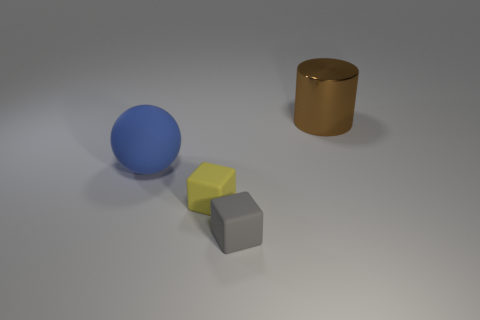Is there anything else that has the same material as the brown cylinder?
Provide a short and direct response. No. There is a big thing in front of the large thing behind the large blue rubber thing; are there any large objects behind it?
Your answer should be very brief. Yes. There is a matte cube behind the gray object; how big is it?
Offer a very short reply. Small. What material is the brown cylinder that is the same size as the blue thing?
Your answer should be very brief. Metal. Does the gray rubber thing have the same shape as the yellow object?
Provide a succinct answer. Yes. How many objects are either large purple matte blocks or big objects that are to the left of the large brown object?
Ensure brevity in your answer.  1. Is the size of the matte object to the left of the yellow matte cube the same as the brown metallic object?
Make the answer very short. Yes. How many brown metal things are on the left side of the big thing that is to the left of the thing behind the big blue matte thing?
Provide a succinct answer. 0. What number of green objects are cylinders or rubber objects?
Give a very brief answer. 0. There is a small cube that is made of the same material as the tiny gray object; what color is it?
Make the answer very short. Yellow. 